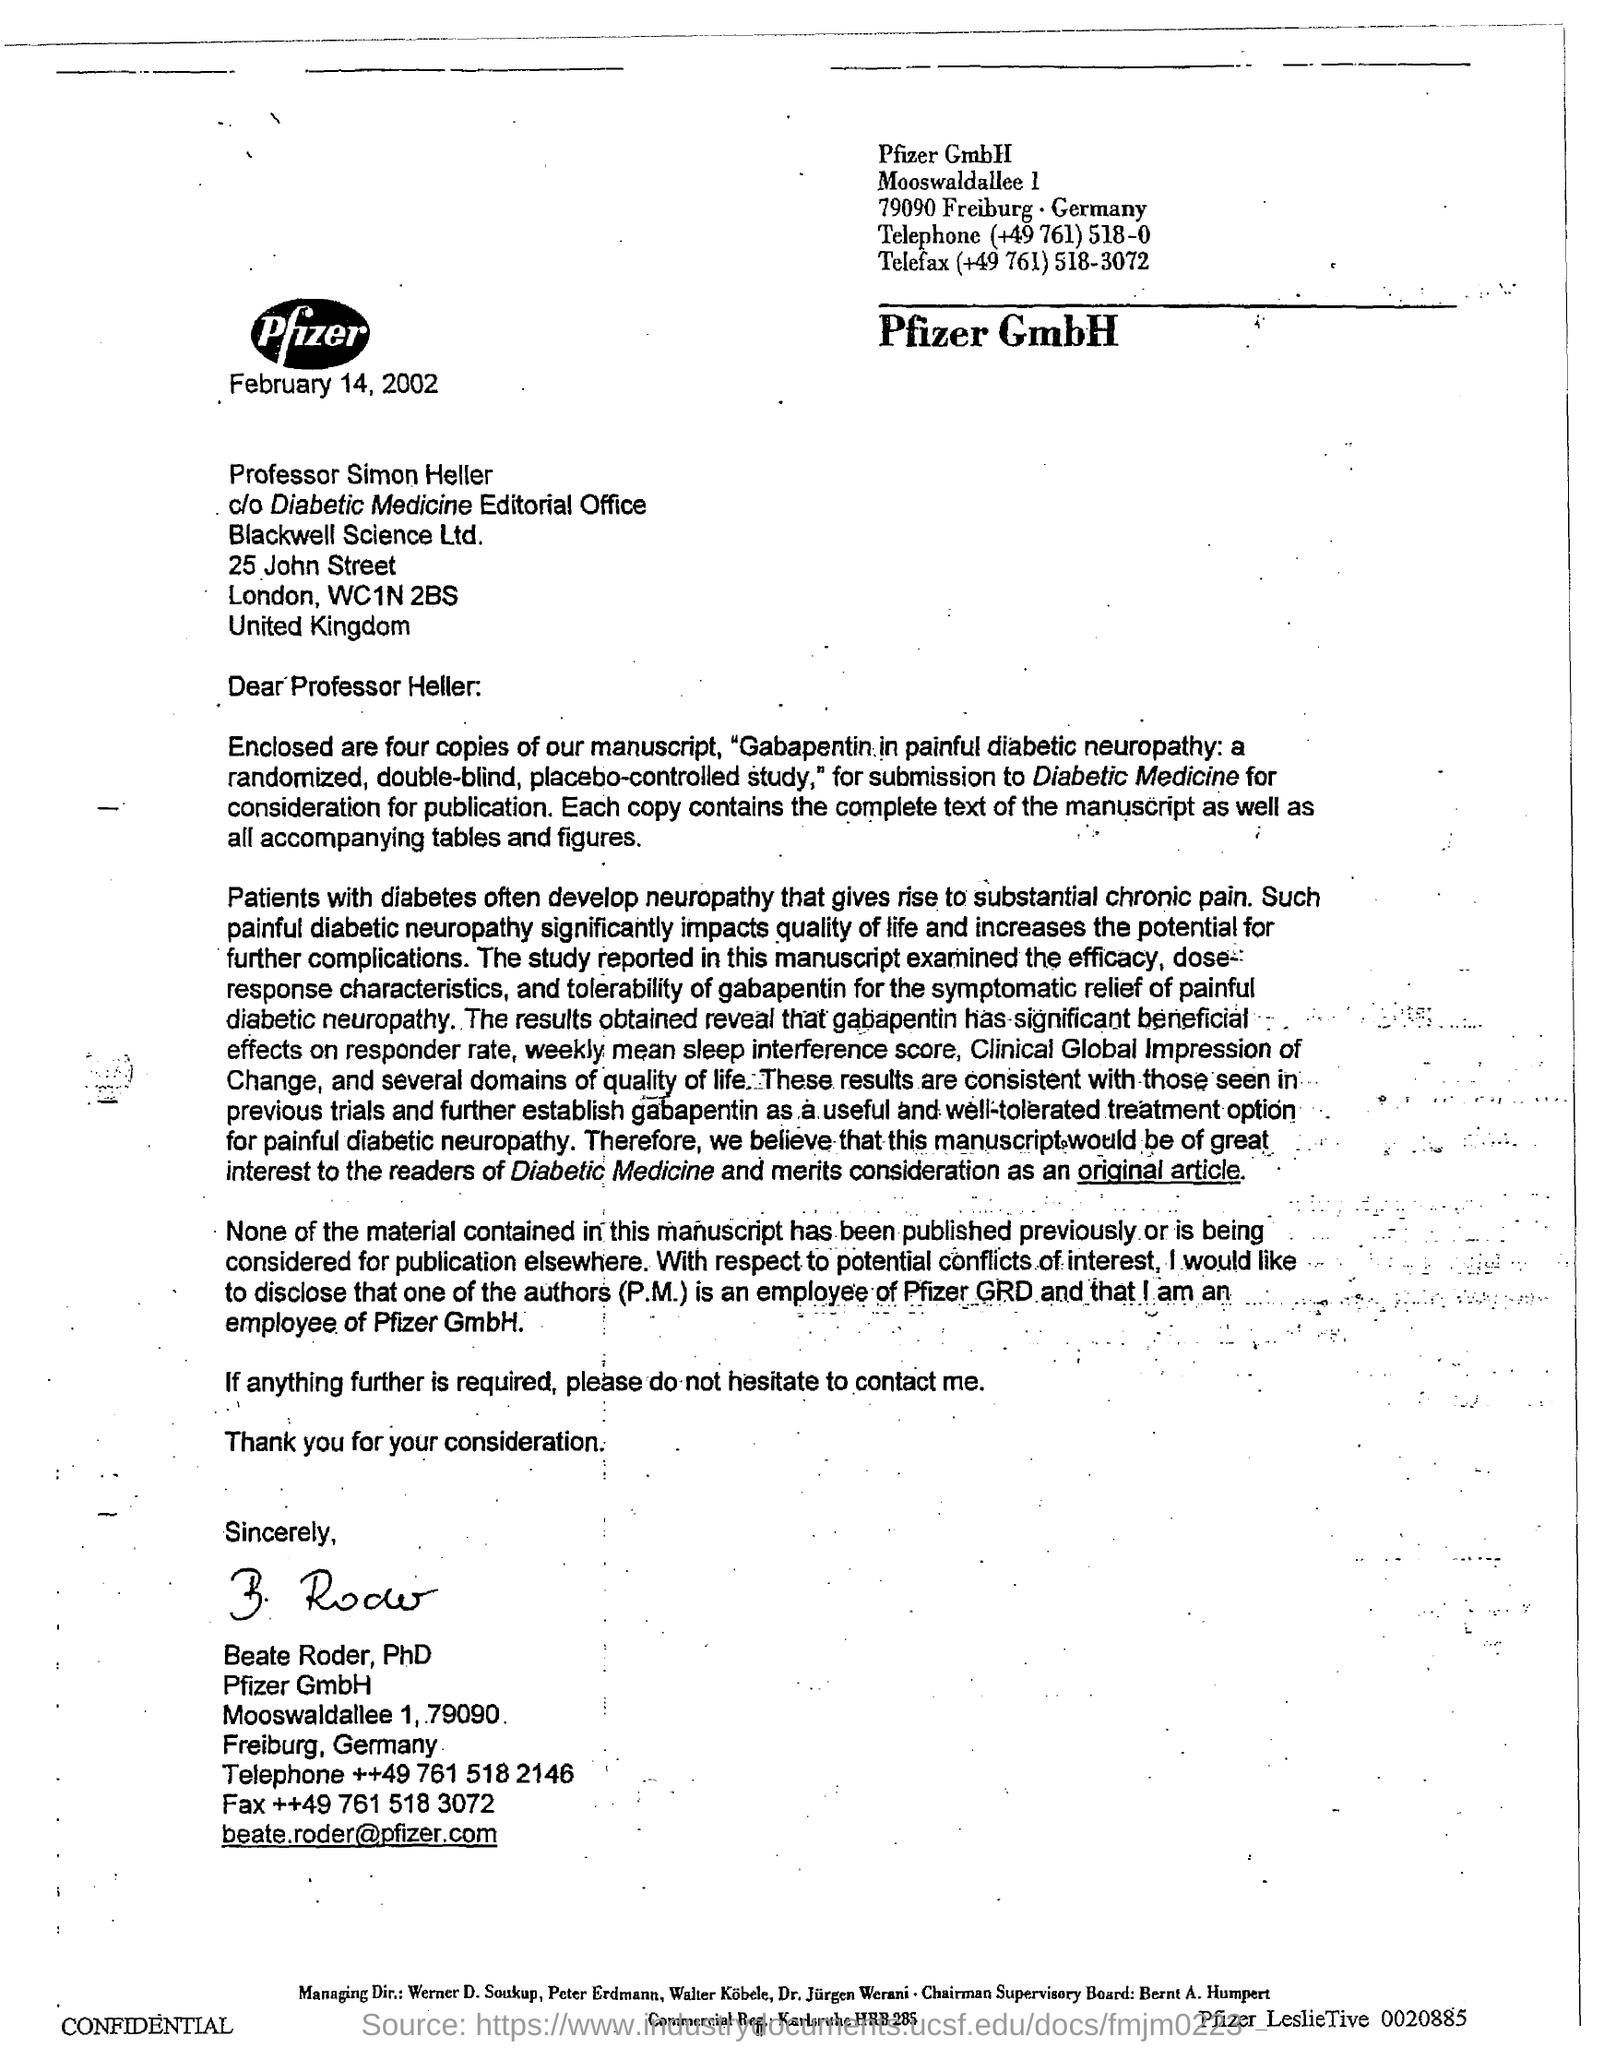Who has signed this letter?
Provide a succinct answer. Beate Roder, PhD. What is the date mentioned in this letter?
Keep it short and to the point. February 14, 2002. 